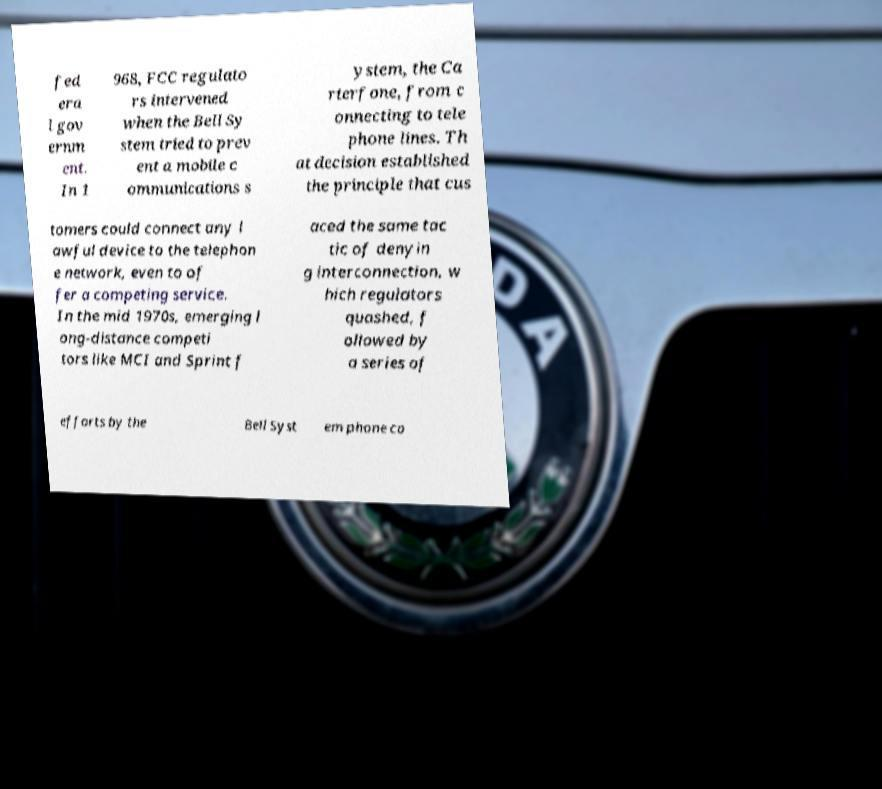Can you accurately transcribe the text from the provided image for me? fed era l gov ernm ent. In 1 968, FCC regulato rs intervened when the Bell Sy stem tried to prev ent a mobile c ommunications s ystem, the Ca rterfone, from c onnecting to tele phone lines. Th at decision established the principle that cus tomers could connect any l awful device to the telephon e network, even to of fer a competing service. In the mid 1970s, emerging l ong-distance competi tors like MCI and Sprint f aced the same tac tic of denyin g interconnection, w hich regulators quashed, f ollowed by a series of efforts by the Bell Syst em phone co 